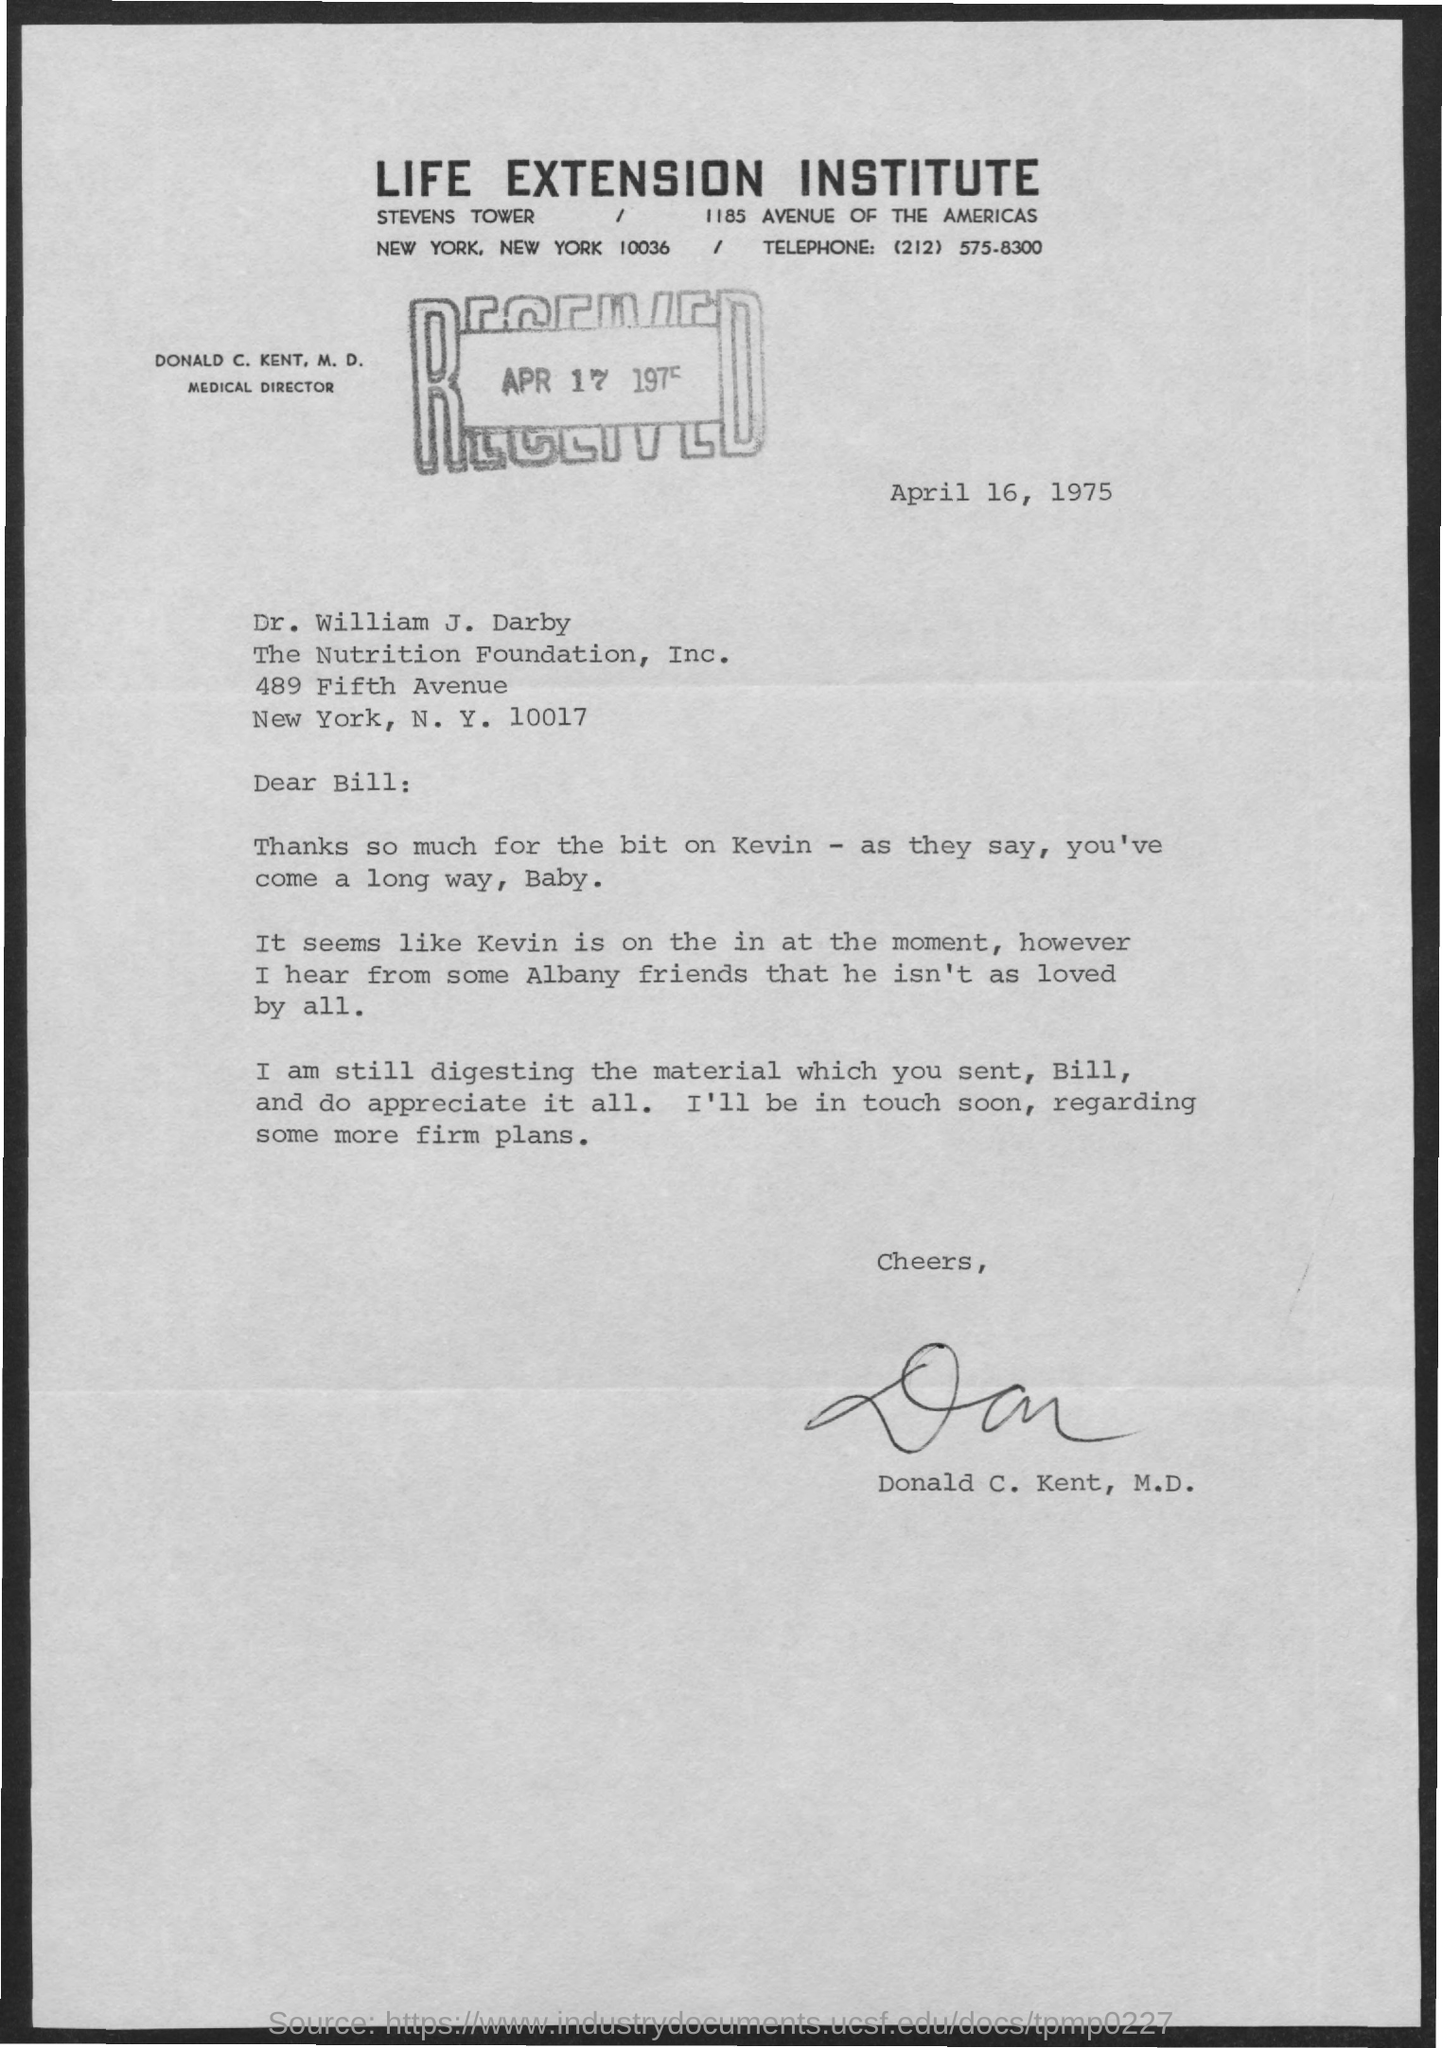Which institute is mentioned?
Your response must be concise. Life Extension Institute. When was the letter received?
Give a very brief answer. APR 17 1975. When is the document dated?
Your answer should be compact. April 16, 1975. To whom is the letter addressed?
Keep it short and to the point. Bill. Who is the sender?
Offer a very short reply. Donald C. Kent, M.D. What is Donald C. Kent's designation?
Your answer should be compact. MEDICAL DIRECTOR. What is the institute's telephone number?
Offer a terse response. (212) 575-8300. 